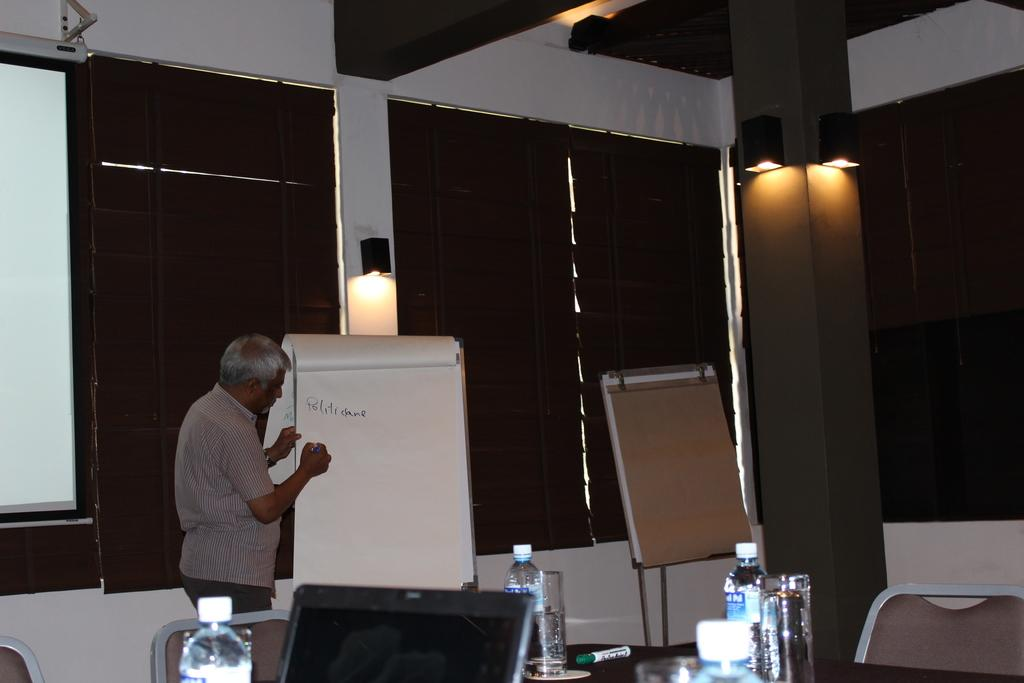What is the man in the image doing? The man is writing on a whiteboard. Can you describe the lighting in the image? There are lights on pillars in the image. What electronic device is on the table? There is a laptop on the table. What items can be seen on the table besides the laptop? There are bottles, a marker, and glasses on the table. What type of furniture is visible in the image? Chairs are visible in the image. What type of patch is sewn onto the side of the man's shirt in the image? There is no patch visible on the man's shirt in the image. How does the man stop writing on the whiteboard in the image? The image does not show the man stopping his writing, so it cannot be determined from the image. 